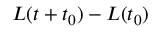Convert formula to latex. <formula><loc_0><loc_0><loc_500><loc_500>L ( t + t _ { 0 } ) - L ( t _ { 0 } )</formula> 